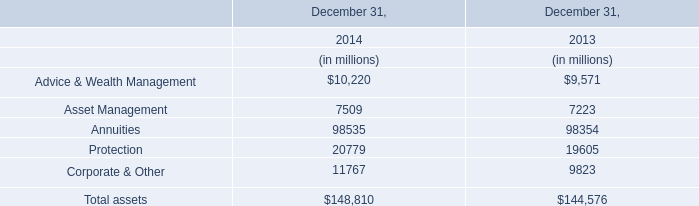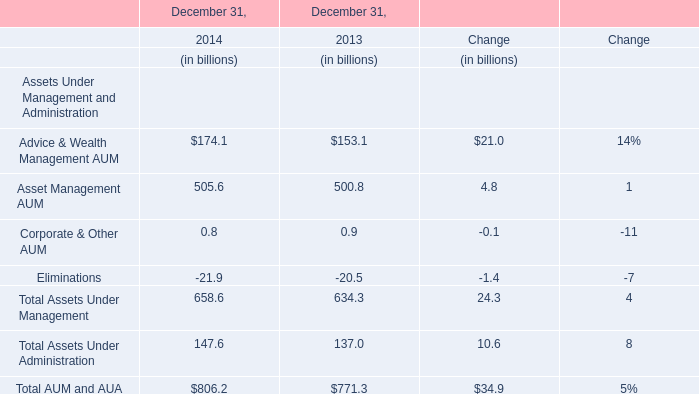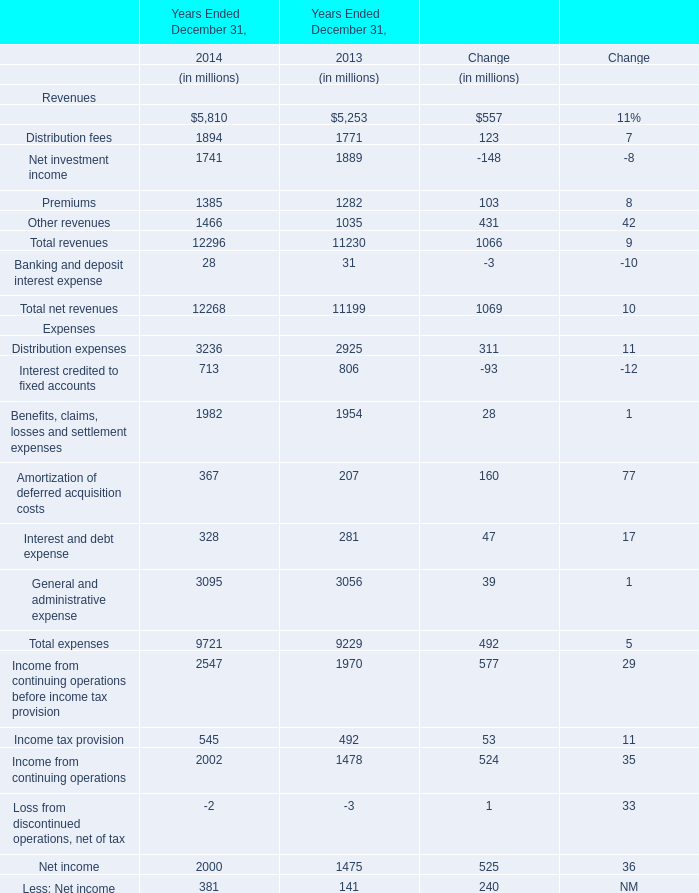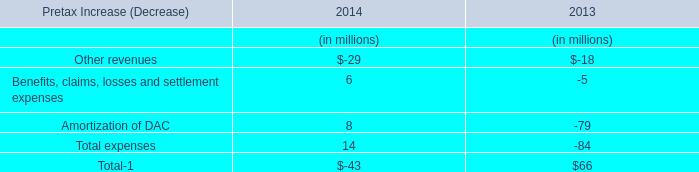In the year with lowest amount of Asset Management AUM what's the increasing rate of Total Assets Under Management? 
Computations: (24.3 / 634.3)
Answer: 0.03831. 